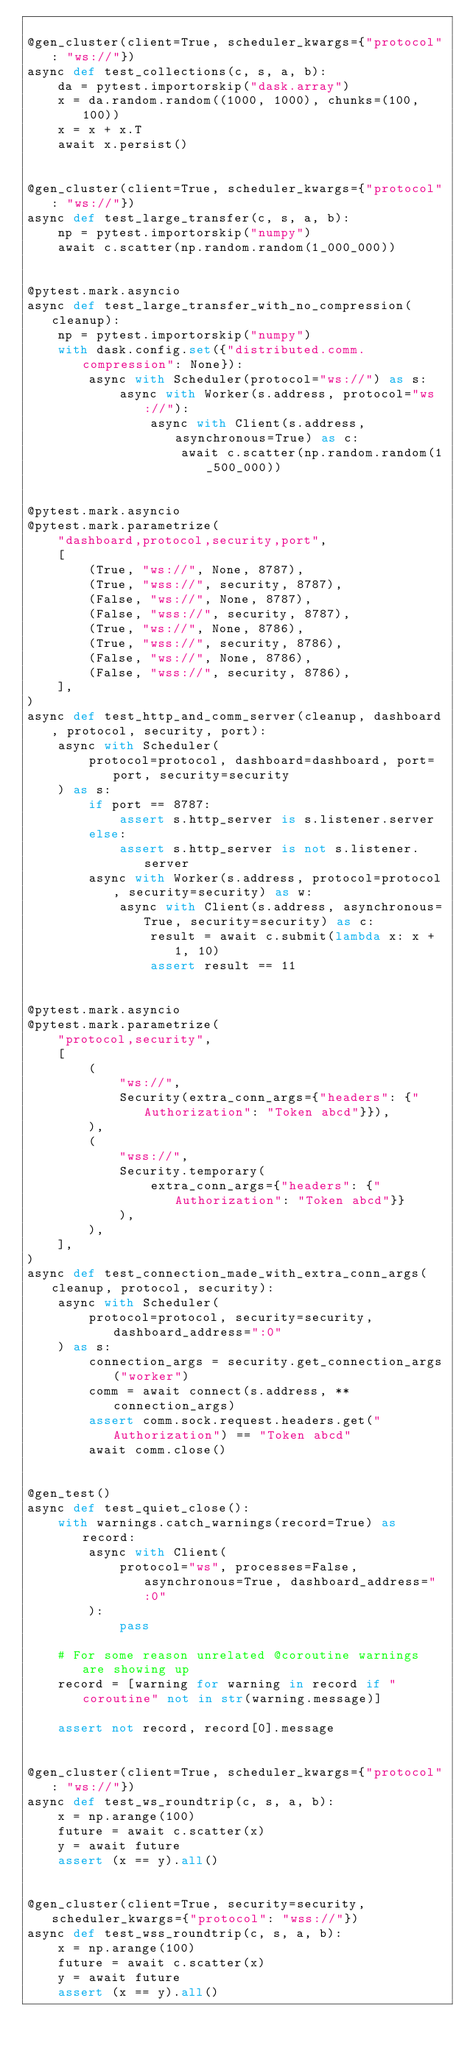<code> <loc_0><loc_0><loc_500><loc_500><_Python_>
@gen_cluster(client=True, scheduler_kwargs={"protocol": "ws://"})
async def test_collections(c, s, a, b):
    da = pytest.importorskip("dask.array")
    x = da.random.random((1000, 1000), chunks=(100, 100))
    x = x + x.T
    await x.persist()


@gen_cluster(client=True, scheduler_kwargs={"protocol": "ws://"})
async def test_large_transfer(c, s, a, b):
    np = pytest.importorskip("numpy")
    await c.scatter(np.random.random(1_000_000))


@pytest.mark.asyncio
async def test_large_transfer_with_no_compression(cleanup):
    np = pytest.importorskip("numpy")
    with dask.config.set({"distributed.comm.compression": None}):
        async with Scheduler(protocol="ws://") as s:
            async with Worker(s.address, protocol="ws://"):
                async with Client(s.address, asynchronous=True) as c:
                    await c.scatter(np.random.random(1_500_000))


@pytest.mark.asyncio
@pytest.mark.parametrize(
    "dashboard,protocol,security,port",
    [
        (True, "ws://", None, 8787),
        (True, "wss://", security, 8787),
        (False, "ws://", None, 8787),
        (False, "wss://", security, 8787),
        (True, "ws://", None, 8786),
        (True, "wss://", security, 8786),
        (False, "ws://", None, 8786),
        (False, "wss://", security, 8786),
    ],
)
async def test_http_and_comm_server(cleanup, dashboard, protocol, security, port):
    async with Scheduler(
        protocol=protocol, dashboard=dashboard, port=port, security=security
    ) as s:
        if port == 8787:
            assert s.http_server is s.listener.server
        else:
            assert s.http_server is not s.listener.server
        async with Worker(s.address, protocol=protocol, security=security) as w:
            async with Client(s.address, asynchronous=True, security=security) as c:
                result = await c.submit(lambda x: x + 1, 10)
                assert result == 11


@pytest.mark.asyncio
@pytest.mark.parametrize(
    "protocol,security",
    [
        (
            "ws://",
            Security(extra_conn_args={"headers": {"Authorization": "Token abcd"}}),
        ),
        (
            "wss://",
            Security.temporary(
                extra_conn_args={"headers": {"Authorization": "Token abcd"}}
            ),
        ),
    ],
)
async def test_connection_made_with_extra_conn_args(cleanup, protocol, security):
    async with Scheduler(
        protocol=protocol, security=security, dashboard_address=":0"
    ) as s:
        connection_args = security.get_connection_args("worker")
        comm = await connect(s.address, **connection_args)
        assert comm.sock.request.headers.get("Authorization") == "Token abcd"
        await comm.close()


@gen_test()
async def test_quiet_close():
    with warnings.catch_warnings(record=True) as record:
        async with Client(
            protocol="ws", processes=False, asynchronous=True, dashboard_address=":0"
        ):
            pass

    # For some reason unrelated @coroutine warnings are showing up
    record = [warning for warning in record if "coroutine" not in str(warning.message)]

    assert not record, record[0].message


@gen_cluster(client=True, scheduler_kwargs={"protocol": "ws://"})
async def test_ws_roundtrip(c, s, a, b):
    x = np.arange(100)
    future = await c.scatter(x)
    y = await future
    assert (x == y).all()


@gen_cluster(client=True, security=security, scheduler_kwargs={"protocol": "wss://"})
async def test_wss_roundtrip(c, s, a, b):
    x = np.arange(100)
    future = await c.scatter(x)
    y = await future
    assert (x == y).all()
</code> 